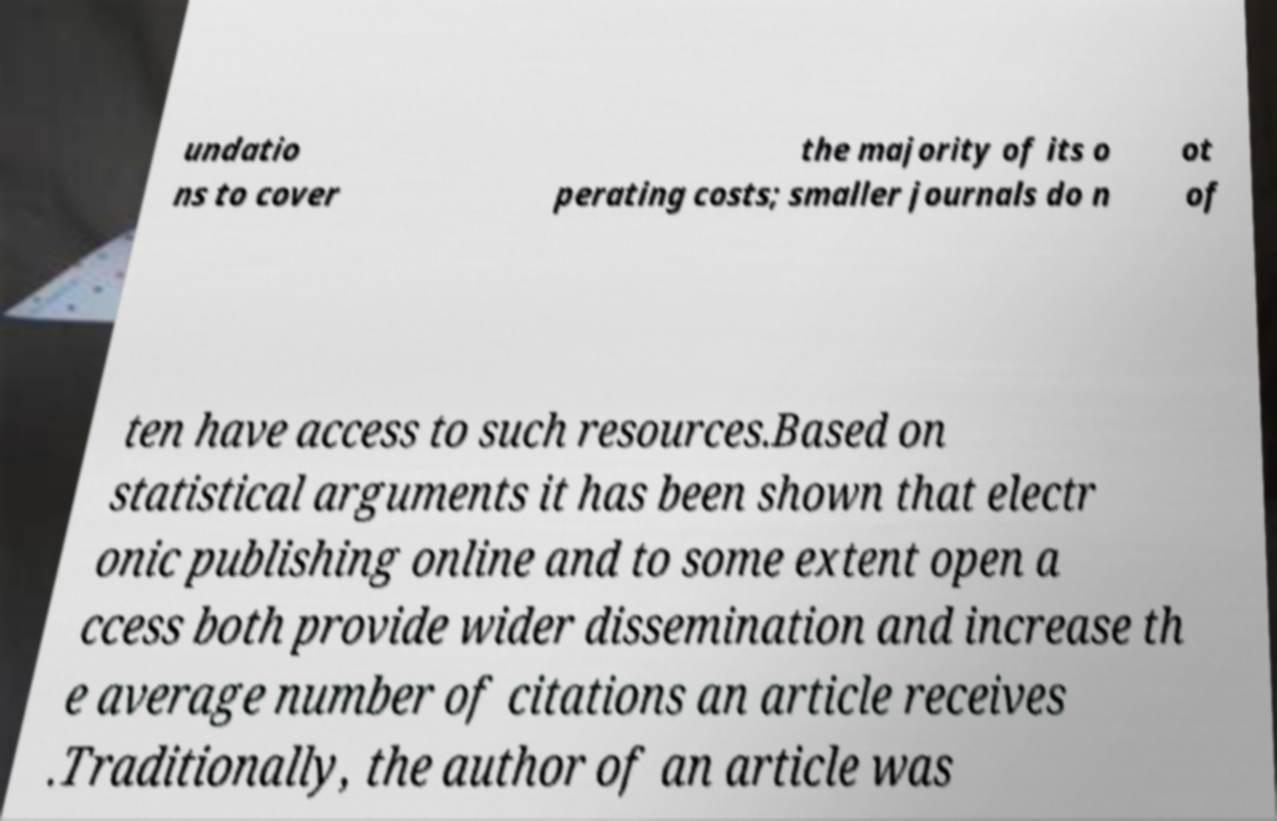Can you accurately transcribe the text from the provided image for me? undatio ns to cover the majority of its o perating costs; smaller journals do n ot of ten have access to such resources.Based on statistical arguments it has been shown that electr onic publishing online and to some extent open a ccess both provide wider dissemination and increase th e average number of citations an article receives .Traditionally, the author of an article was 